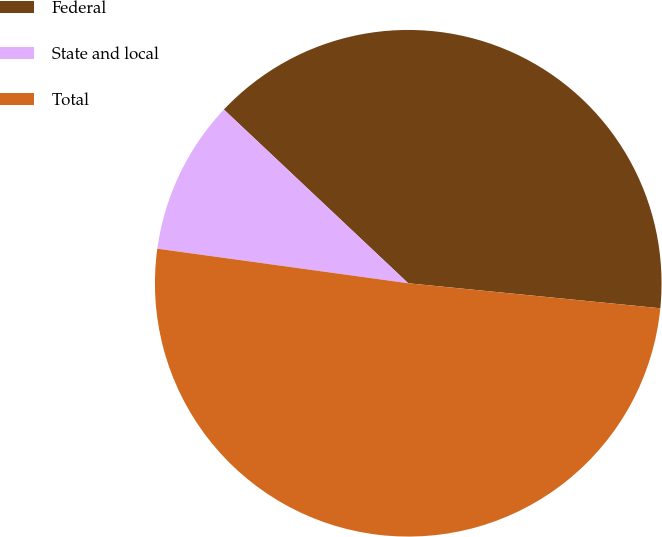<chart> <loc_0><loc_0><loc_500><loc_500><pie_chart><fcel>Federal<fcel>State and local<fcel>Total<nl><fcel>39.55%<fcel>9.85%<fcel>50.61%<nl></chart> 